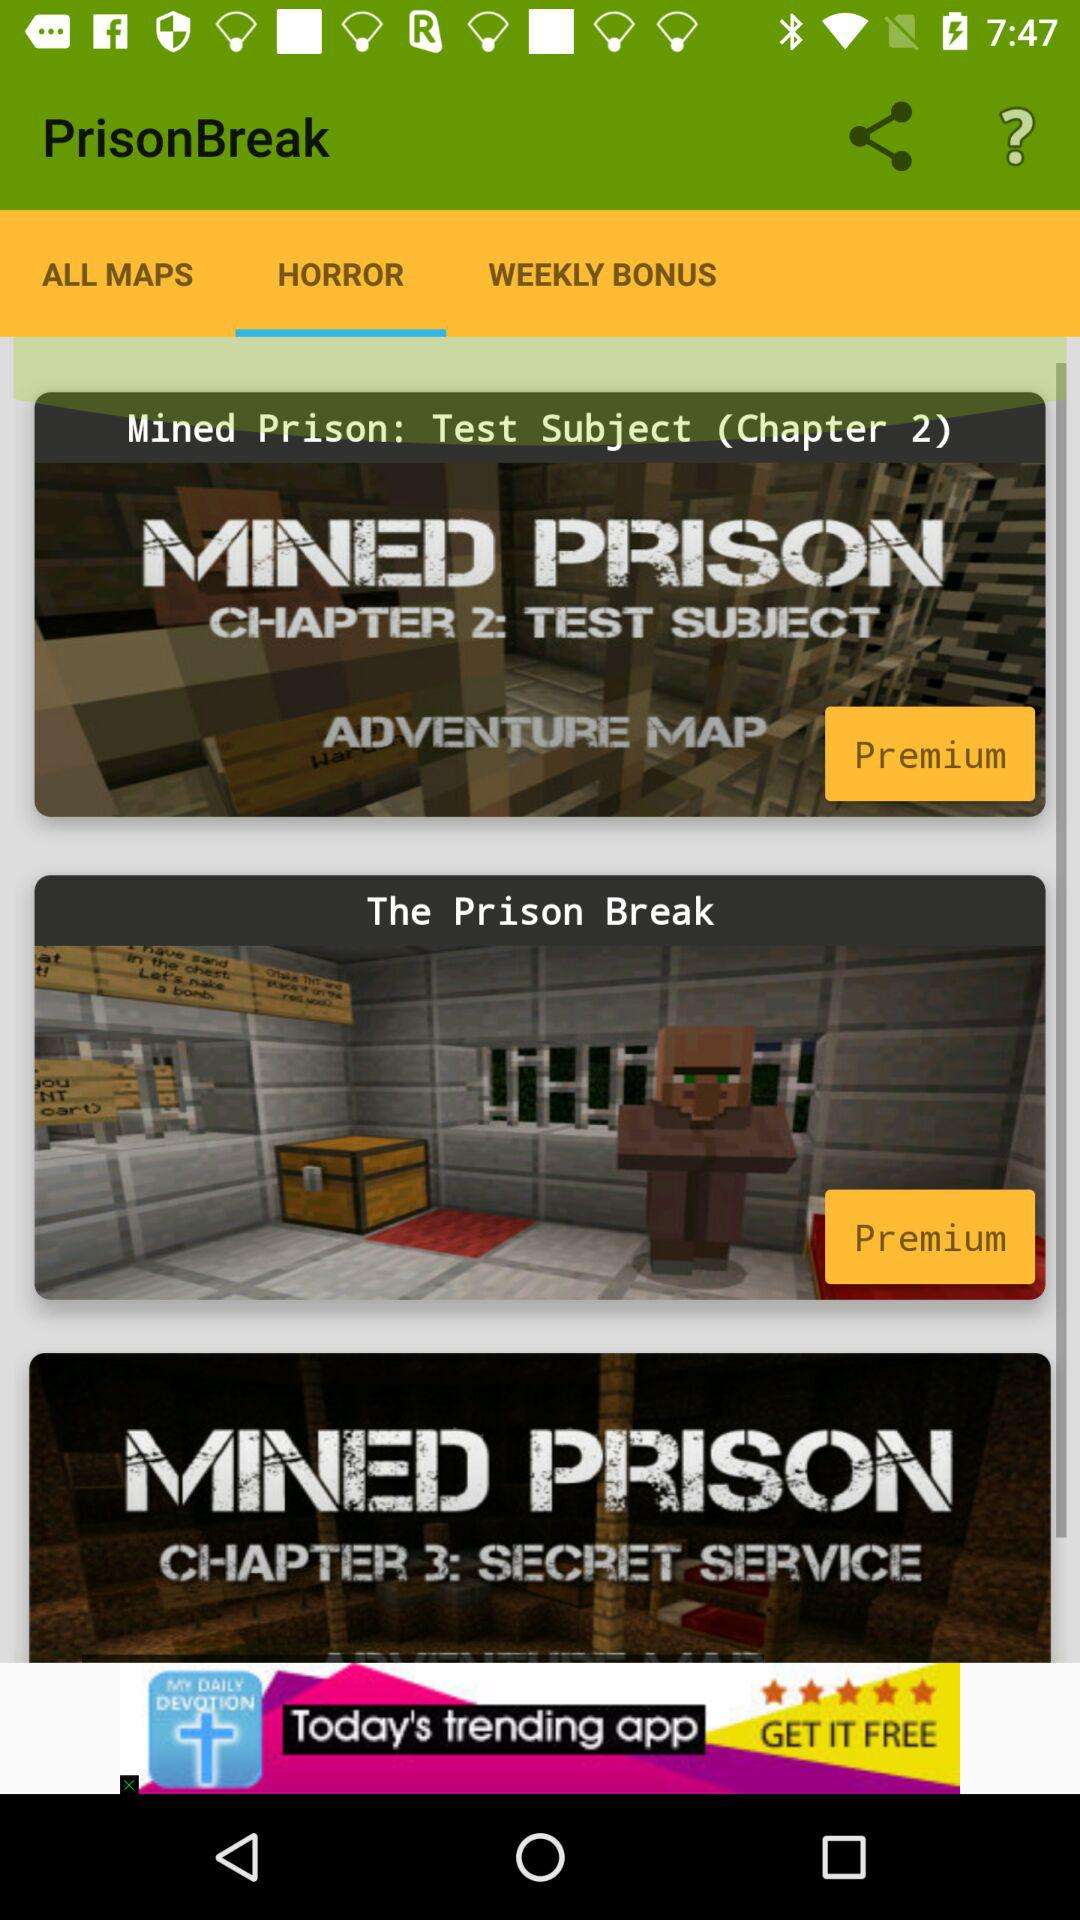Which option is selected in "PrisonBreak"? The selected option is "HORROR". 